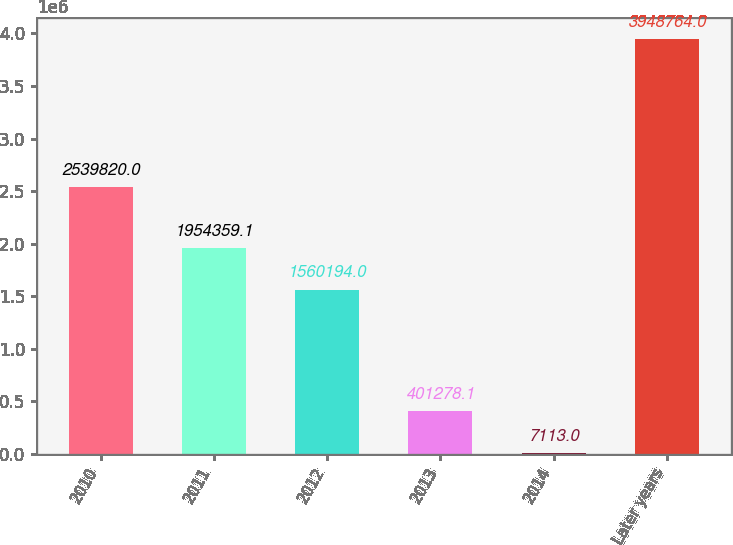<chart> <loc_0><loc_0><loc_500><loc_500><bar_chart><fcel>2010<fcel>2011<fcel>2012<fcel>2013<fcel>2014<fcel>Later years<nl><fcel>2.53982e+06<fcel>1.95436e+06<fcel>1.56019e+06<fcel>401278<fcel>7113<fcel>3.94876e+06<nl></chart> 